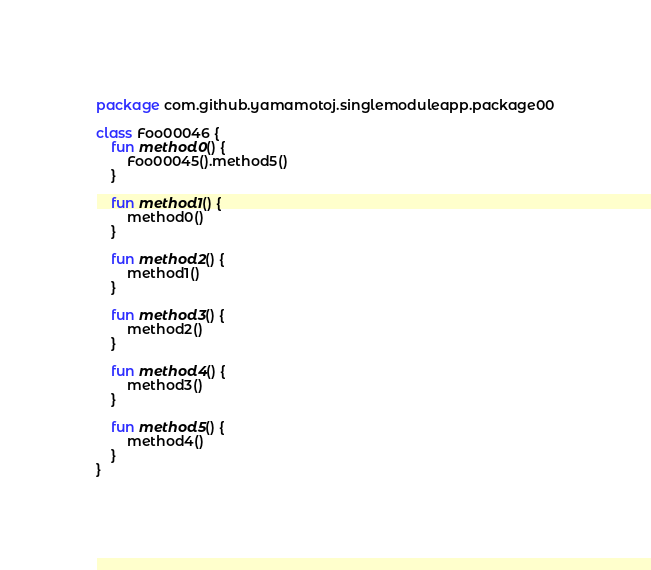<code> <loc_0><loc_0><loc_500><loc_500><_Kotlin_>package com.github.yamamotoj.singlemoduleapp.package00

class Foo00046 {
    fun method0() {
        Foo00045().method5()
    }

    fun method1() {
        method0()
    }

    fun method2() {
        method1()
    }

    fun method3() {
        method2()
    }

    fun method4() {
        method3()
    }

    fun method5() {
        method4()
    }
}
</code> 